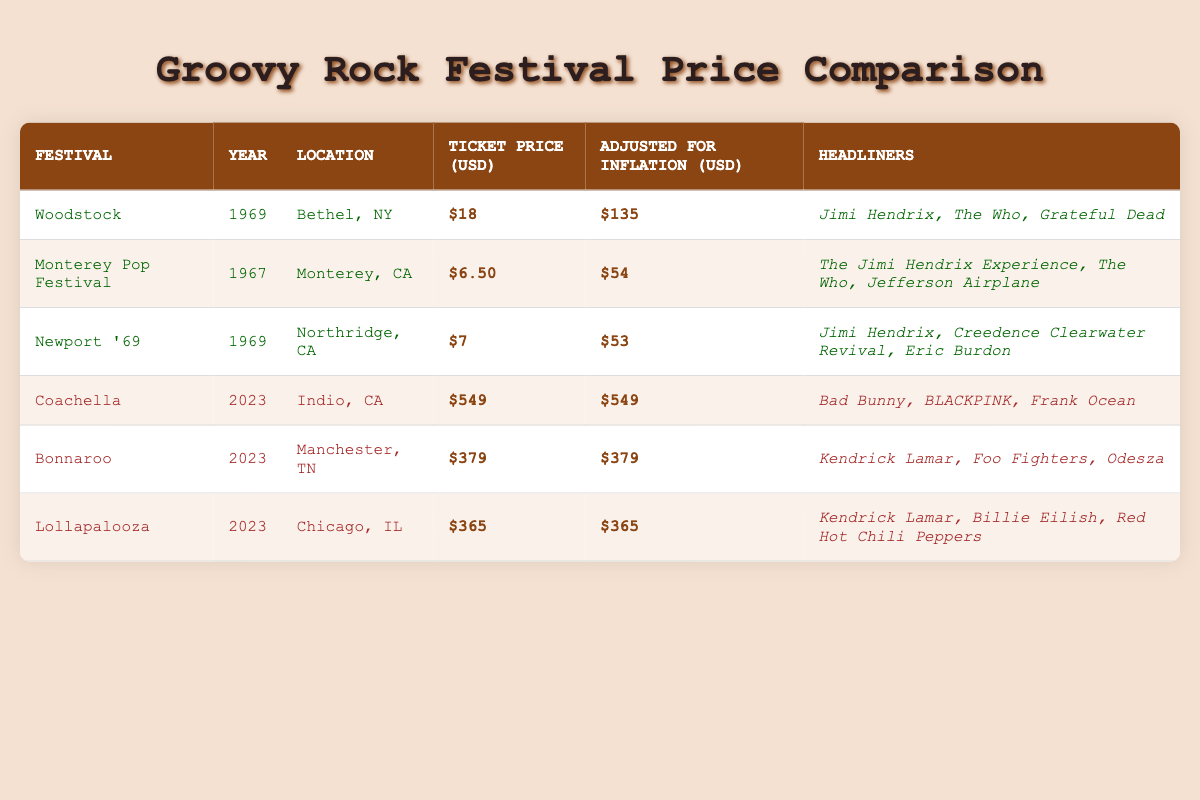What is the ticket price for Woodstock in 1969? The ticket price for Woodstock in 1969 is listed in the table under the “Ticket Price (USD)” column for that festival.
Answer: $18 What is the adjusted price for a Monterey Pop Festival ticket in today’s dollars? The adjusted price for the Monterey Pop Festival ticket is found under the "Adjusted for Inflation (USD)" column. For the festival, it is $54.
Answer: $54 Which festival had the highest ticket price in 2023? To answer this, compare the ticket prices listed in the "Ticket Price (USD)" column for the festivals in 2023 (Coachella, Bonnaroo, Lollapalooza). Coachella has the highest price of $549.
Answer: Coachella Is the ticket price for Newport '69 higher than the adjusted price for Monterey Pop Festival? The ticket price for Newport '69 is $7, and the adjusted price for Monterey Pop Festival is $54. Since $7 is less than $54, the answer is no.
Answer: No What is the average ticket price for all festivals listed in the table? To find the average, sum all the ticket prices: 18 + 6.50 + 7 + 549 + 379 + 365 = 1324. Then, divide by the number of festivals (6): 1324/6 = approximately 220.67.
Answer: 220.67 What is the difference in ticket prices between the most expensive festival today and the cheapest festival from the late 60s? The most expensive festival today is Coachella with a price of $549, and the cheapest from the 60s is Monterey Pop Festival at $6. The difference is calculated as: 549 - 6 = 543.
Answer: 543 Are there any festivals from the late 60s that had headliners including Jimi Hendrix? Two festivals from the late 60s, Woodstock and Newport '69, featured Jimi Hendrix as a headliner. Therefore, the answer is yes.
Answer: Yes How much has the ticket price increased from the Newport '69 to the Coachella festival in 2023? The ticket price for Newport '69 is $7, and for Coachella, it is $549. The increase is calculated as: 549 - 7 = 542.
Answer: 542 Name the headliners of the Bonnaroo festival. The headliners for the Bonnaroo festival can be found in the "Headliners" column for that festival. They are Kendrick Lamar, Foo Fighters, and Odesza.
Answer: Kendrick Lamar, Foo Fighters, Odesza 